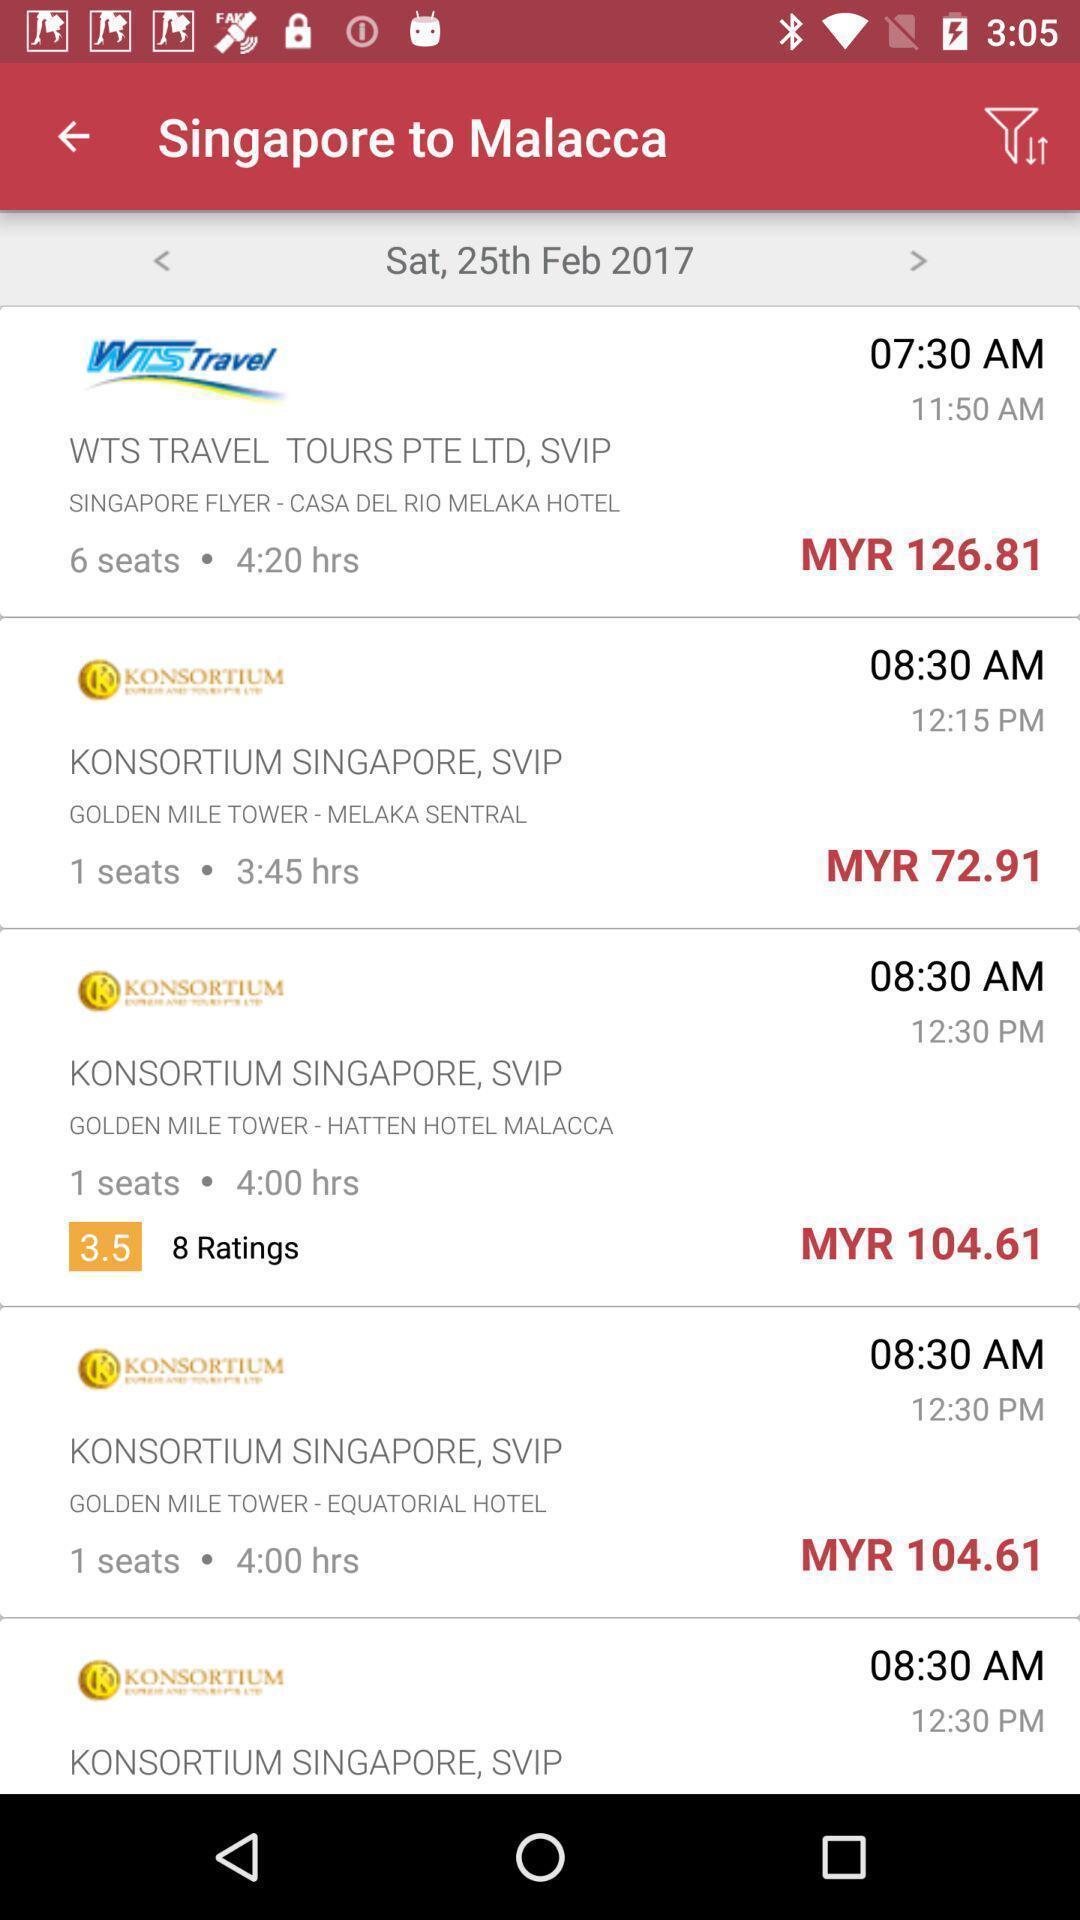Summarize the information in this screenshot. Page displaying various information. 